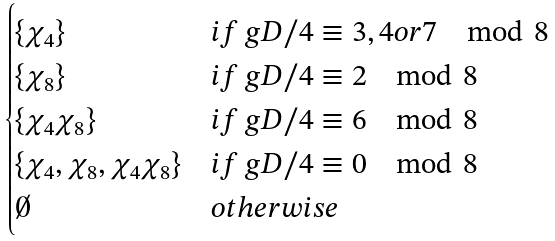Convert formula to latex. <formula><loc_0><loc_0><loc_500><loc_500>\begin{cases} \{ \chi _ { 4 } \} & i f \ g D / 4 \equiv 3 , 4 o r 7 \mod 8 \\ \{ \chi _ { 8 } \} & i f \ g D / 4 \equiv 2 \mod 8 \\ \{ \chi _ { 4 } \chi _ { 8 } \} & i f \ g D / 4 \equiv 6 \mod 8 \\ \{ \chi _ { 4 } , \chi _ { 8 } , \chi _ { 4 } \chi _ { 8 } \} & i f \ g D / 4 \equiv 0 \mod 8 \\ \emptyset & o t h e r w i s e \end{cases}</formula> 